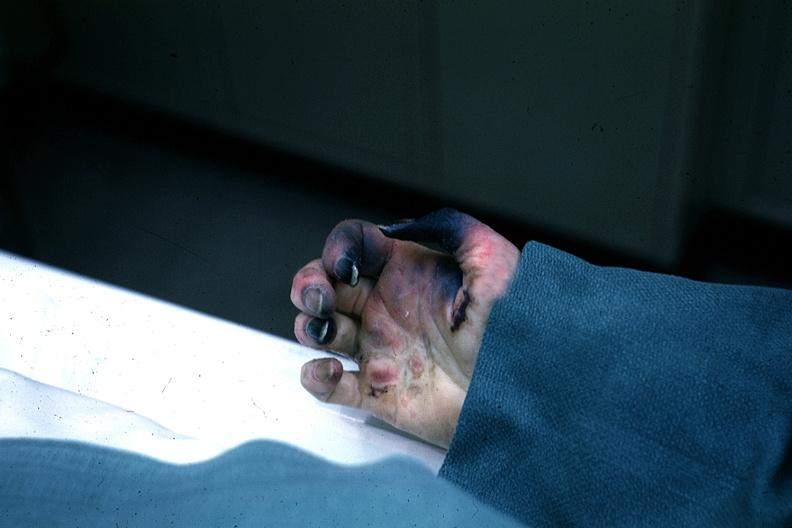what does this image show?
Answer the question using a single word or phrase. Excellent gangrenous necrosis of fingers said to be due to embolism 